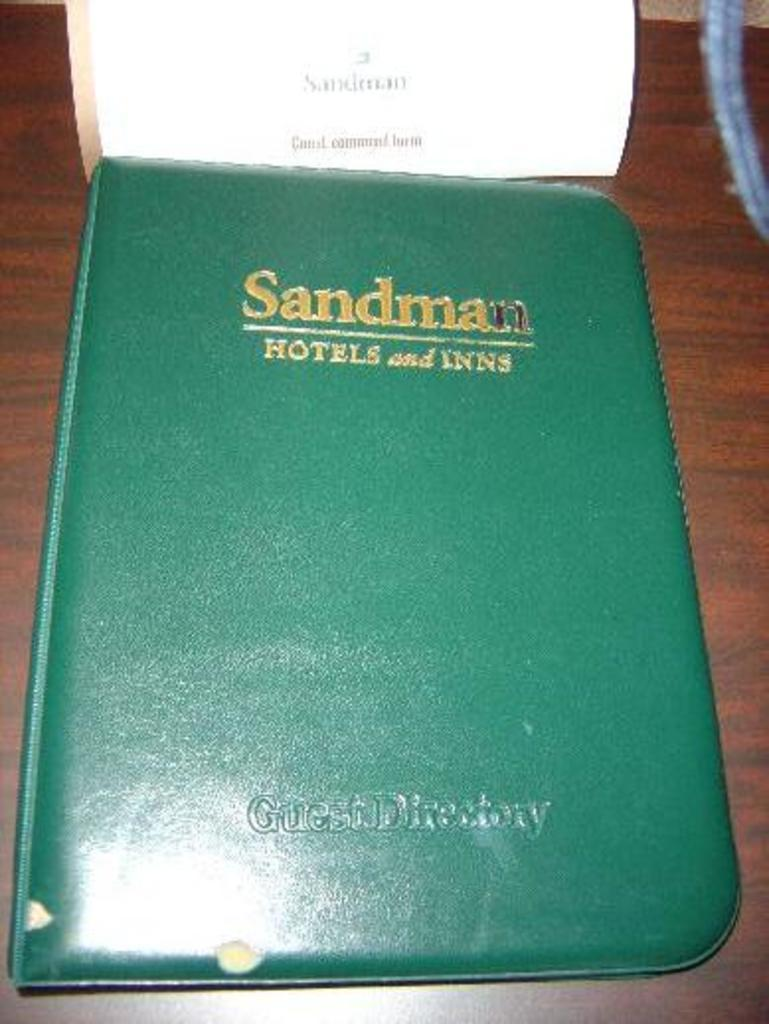Provide a one-sentence caption for the provided image. The green book on the table is a guest directory. 